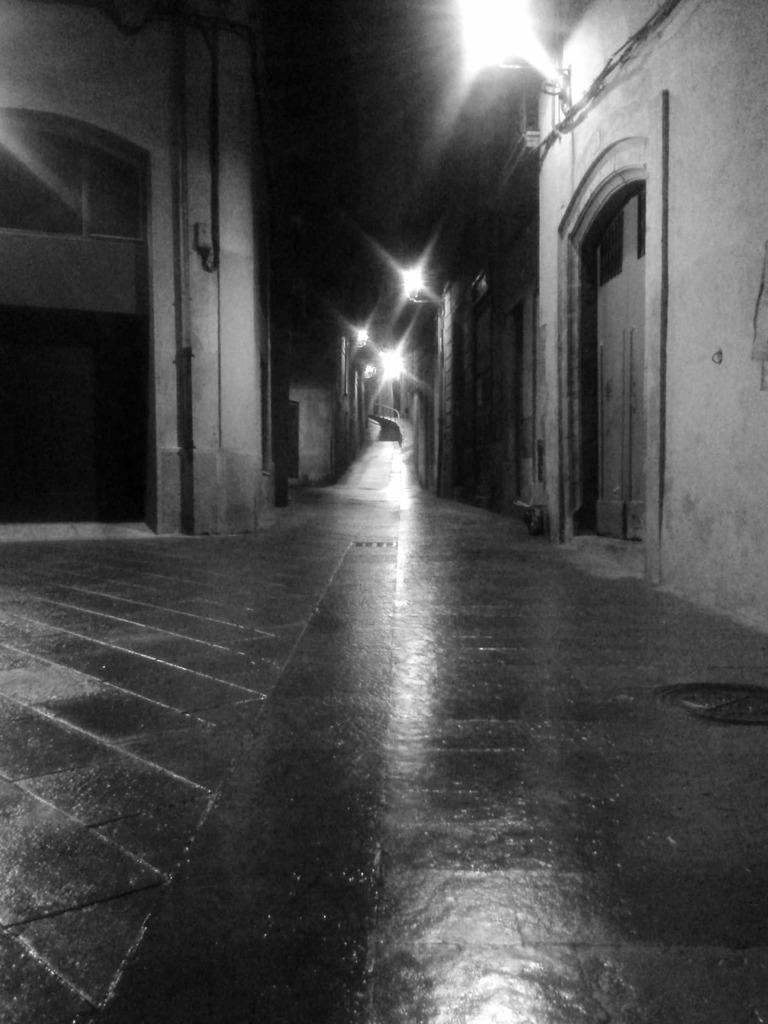How would you summarize this image in a sentence or two? In this picture we can see many buildings. On the right and left side there is a door. On the wall we can see many lights. At the top we can see the darkness. 